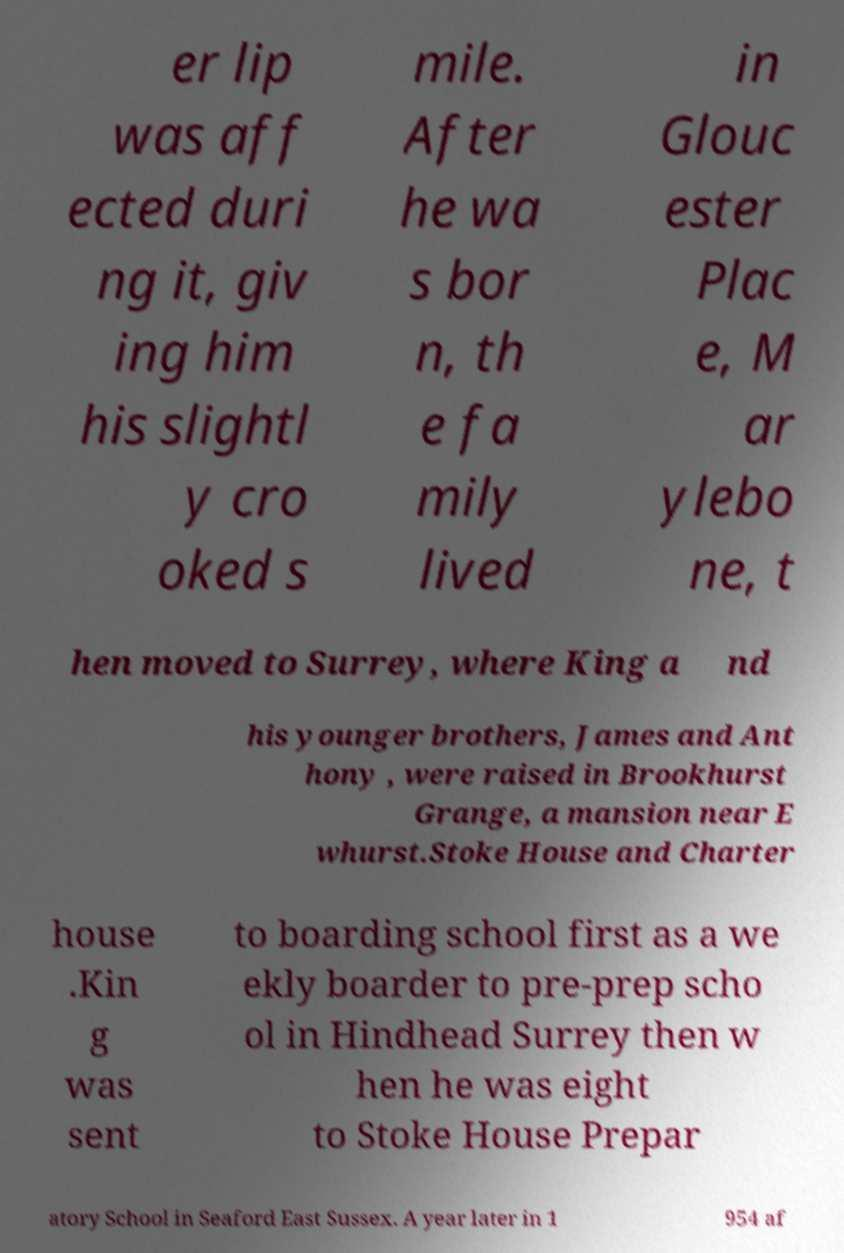Please read and relay the text visible in this image. What does it say? er lip was aff ected duri ng it, giv ing him his slightl y cro oked s mile. After he wa s bor n, th e fa mily lived in Glouc ester Plac e, M ar ylebo ne, t hen moved to Surrey, where King a nd his younger brothers, James and Ant hony , were raised in Brookhurst Grange, a mansion near E whurst.Stoke House and Charter house .Kin g was sent to boarding school first as a we ekly boarder to pre-prep scho ol in Hindhead Surrey then w hen he was eight to Stoke House Prepar atory School in Seaford East Sussex. A year later in 1 954 af 